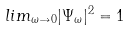Convert formula to latex. <formula><loc_0><loc_0><loc_500><loc_500>l i m _ { \omega \to 0 } | \Psi _ { \omega } | ^ { 2 } = 1</formula> 